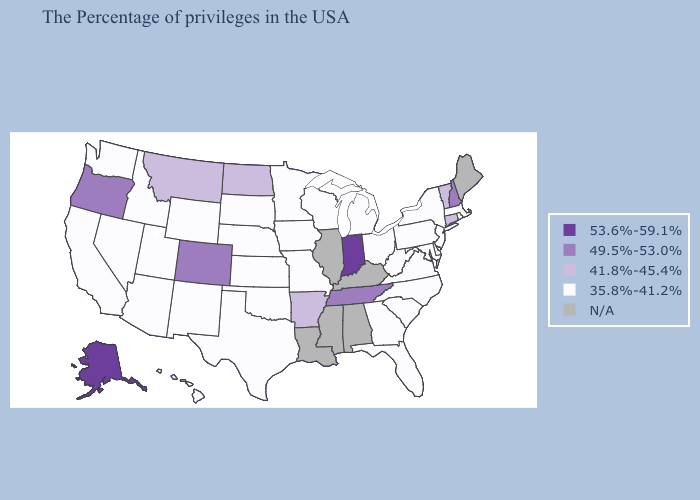Name the states that have a value in the range 49.5%-53.0%?
Answer briefly. New Hampshire, Tennessee, Colorado, Oregon. Does Tennessee have the lowest value in the South?
Concise answer only. No. Name the states that have a value in the range 41.8%-45.4%?
Answer briefly. Vermont, Connecticut, Arkansas, North Dakota, Montana. Which states hav the highest value in the West?
Give a very brief answer. Alaska. What is the highest value in the Northeast ?
Quick response, please. 49.5%-53.0%. Name the states that have a value in the range 49.5%-53.0%?
Keep it brief. New Hampshire, Tennessee, Colorado, Oregon. Does Florida have the highest value in the USA?
Write a very short answer. No. What is the value of Michigan?
Concise answer only. 35.8%-41.2%. Does Maryland have the highest value in the South?
Short answer required. No. What is the highest value in states that border New Mexico?
Quick response, please. 49.5%-53.0%. How many symbols are there in the legend?
Be succinct. 5. Does Vermont have the highest value in the Northeast?
Short answer required. No. Does Oklahoma have the lowest value in the USA?
Answer briefly. Yes. How many symbols are there in the legend?
Be succinct. 5. 